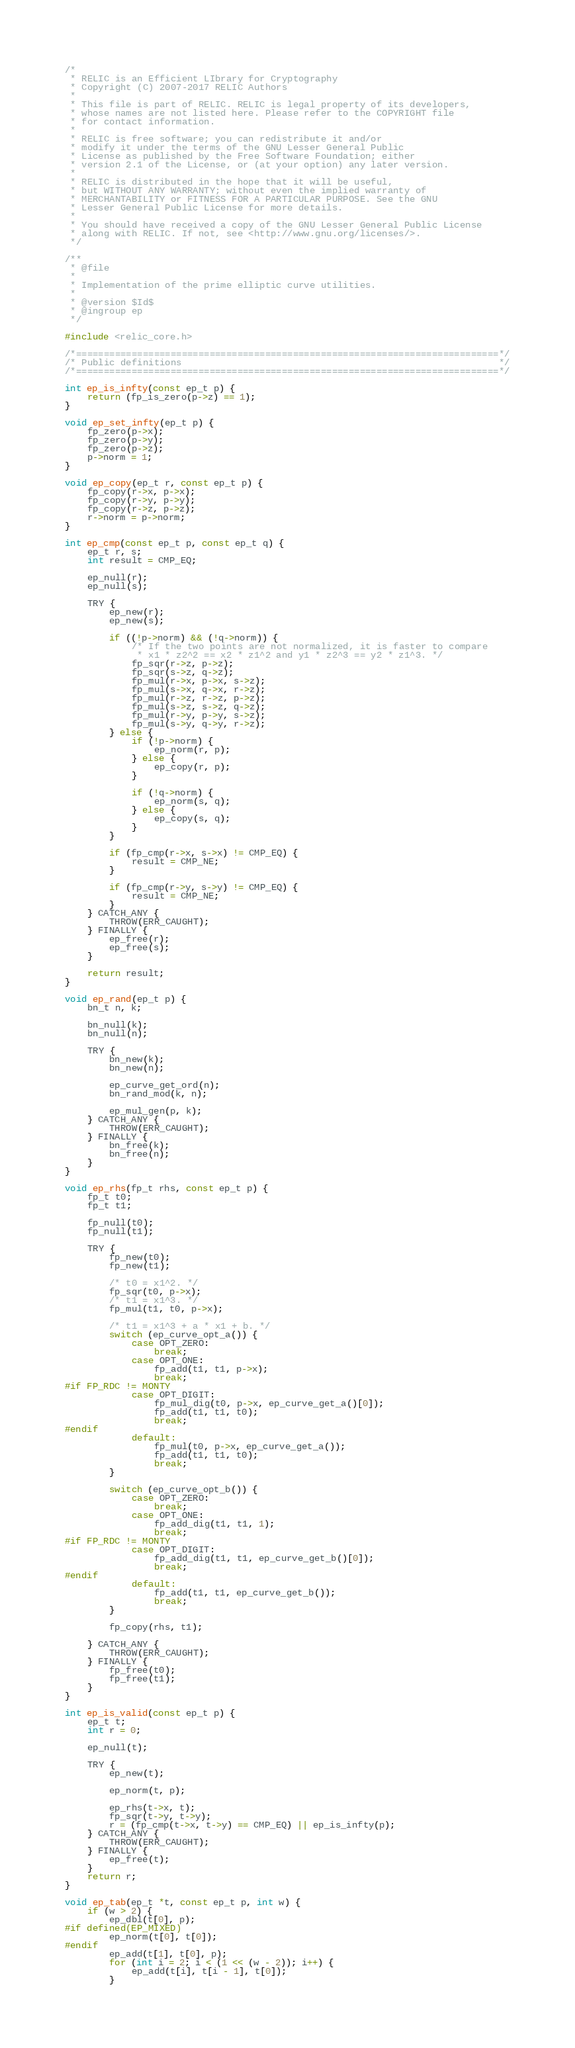Convert code to text. <code><loc_0><loc_0><loc_500><loc_500><_C_>/*
 * RELIC is an Efficient LIbrary for Cryptography
 * Copyright (C) 2007-2017 RELIC Authors
 *
 * This file is part of RELIC. RELIC is legal property of its developers,
 * whose names are not listed here. Please refer to the COPYRIGHT file
 * for contact information.
 *
 * RELIC is free software; you can redistribute it and/or
 * modify it under the terms of the GNU Lesser General Public
 * License as published by the Free Software Foundation; either
 * version 2.1 of the License, or (at your option) any later version.
 *
 * RELIC is distributed in the hope that it will be useful,
 * but WITHOUT ANY WARRANTY; without even the implied warranty of
 * MERCHANTABILITY or FITNESS FOR A PARTICULAR PURPOSE. See the GNU
 * Lesser General Public License for more details.
 *
 * You should have received a copy of the GNU Lesser General Public License
 * along with RELIC. If not, see <http://www.gnu.org/licenses/>.
 */

/**
 * @file
 *
 * Implementation of the prime elliptic curve utilities.
 *
 * @version $Id$
 * @ingroup ep
 */

#include <relic_core.h>

/*============================================================================*/
/* Public definitions                                                         */
/*============================================================================*/

int ep_is_infty(const ep_t p) {
	return (fp_is_zero(p->z) == 1);
}

void ep_set_infty(ep_t p) {
	fp_zero(p->x);
	fp_zero(p->y);
	fp_zero(p->z);
	p->norm = 1;
}

void ep_copy(ep_t r, const ep_t p) {
	fp_copy(r->x, p->x);
	fp_copy(r->y, p->y);
	fp_copy(r->z, p->z);
	r->norm = p->norm;
}

int ep_cmp(const ep_t p, const ep_t q) {
    ep_t r, s;
    int result = CMP_EQ;

    ep_null(r);
    ep_null(s);

    TRY {
        ep_new(r);
        ep_new(s);

        if ((!p->norm) && (!q->norm)) {
            /* If the two points are not normalized, it is faster to compare
             * x1 * z2^2 == x2 * z1^2 and y1 * z2^3 == y2 * z1^3. */
            fp_sqr(r->z, p->z);
            fp_sqr(s->z, q->z);
            fp_mul(r->x, p->x, s->z);
            fp_mul(s->x, q->x, r->z);
            fp_mul(r->z, r->z, p->z);
            fp_mul(s->z, s->z, q->z);
            fp_mul(r->y, p->y, s->z);
            fp_mul(s->y, q->y, r->z);
        } else {
            if (!p->norm) {
                ep_norm(r, p);
            } else {
                ep_copy(r, p);
            }

            if (!q->norm) {
                ep_norm(s, q);
            } else {
                ep_copy(s, q);
            }
        }

        if (fp_cmp(r->x, s->x) != CMP_EQ) {
            result = CMP_NE;
        }

        if (fp_cmp(r->y, s->y) != CMP_EQ) {
            result = CMP_NE;
        }
    } CATCH_ANY {
        THROW(ERR_CAUGHT);
    } FINALLY {
        ep_free(r);
        ep_free(s);
    }

    return result;
}

void ep_rand(ep_t p) {
	bn_t n, k;

	bn_null(k);
	bn_null(n);

	TRY {
		bn_new(k);
		bn_new(n);

		ep_curve_get_ord(n);
		bn_rand_mod(k, n);

		ep_mul_gen(p, k);
	} CATCH_ANY {
		THROW(ERR_CAUGHT);
	} FINALLY {
		bn_free(k);
		bn_free(n);
	}
}

void ep_rhs(fp_t rhs, const ep_t p) {
	fp_t t0;
	fp_t t1;

	fp_null(t0);
	fp_null(t1);

	TRY {
		fp_new(t0);
		fp_new(t1);

		/* t0 = x1^2. */
		fp_sqr(t0, p->x);
		/* t1 = x1^3. */
		fp_mul(t1, t0, p->x);

		/* t1 = x1^3 + a * x1 + b. */
		switch (ep_curve_opt_a()) {
			case OPT_ZERO:
				break;
			case OPT_ONE:
				fp_add(t1, t1, p->x);
				break;
#if FP_RDC != MONTY
			case OPT_DIGIT:
				fp_mul_dig(t0, p->x, ep_curve_get_a()[0]);
				fp_add(t1, t1, t0);
				break;
#endif
			default:
				fp_mul(t0, p->x, ep_curve_get_a());
				fp_add(t1, t1, t0);
				break;
		}

		switch (ep_curve_opt_b()) {
			case OPT_ZERO:
				break;
			case OPT_ONE:
				fp_add_dig(t1, t1, 1);
				break;
#if FP_RDC != MONTY
			case OPT_DIGIT:
				fp_add_dig(t1, t1, ep_curve_get_b()[0]);
				break;
#endif
			default:
				fp_add(t1, t1, ep_curve_get_b());
				break;
		}

		fp_copy(rhs, t1);

	} CATCH_ANY {
		THROW(ERR_CAUGHT);
	} FINALLY {
		fp_free(t0);
		fp_free(t1);
	}
}

int ep_is_valid(const ep_t p) {
	ep_t t;
	int r = 0;

	ep_null(t);

	TRY {
		ep_new(t);

		ep_norm(t, p);

		ep_rhs(t->x, t);
		fp_sqr(t->y, t->y);
		r = (fp_cmp(t->x, t->y) == CMP_EQ) || ep_is_infty(p);
	} CATCH_ANY {
		THROW(ERR_CAUGHT);
	} FINALLY {
		ep_free(t);
	}
	return r;
}

void ep_tab(ep_t *t, const ep_t p, int w) {
	if (w > 2) {
		ep_dbl(t[0], p);
#if defined(EP_MIXED)
		ep_norm(t[0], t[0]);
#endif
		ep_add(t[1], t[0], p);
		for (int i = 2; i < (1 << (w - 2)); i++) {
			ep_add(t[i], t[i - 1], t[0]);
		}</code> 